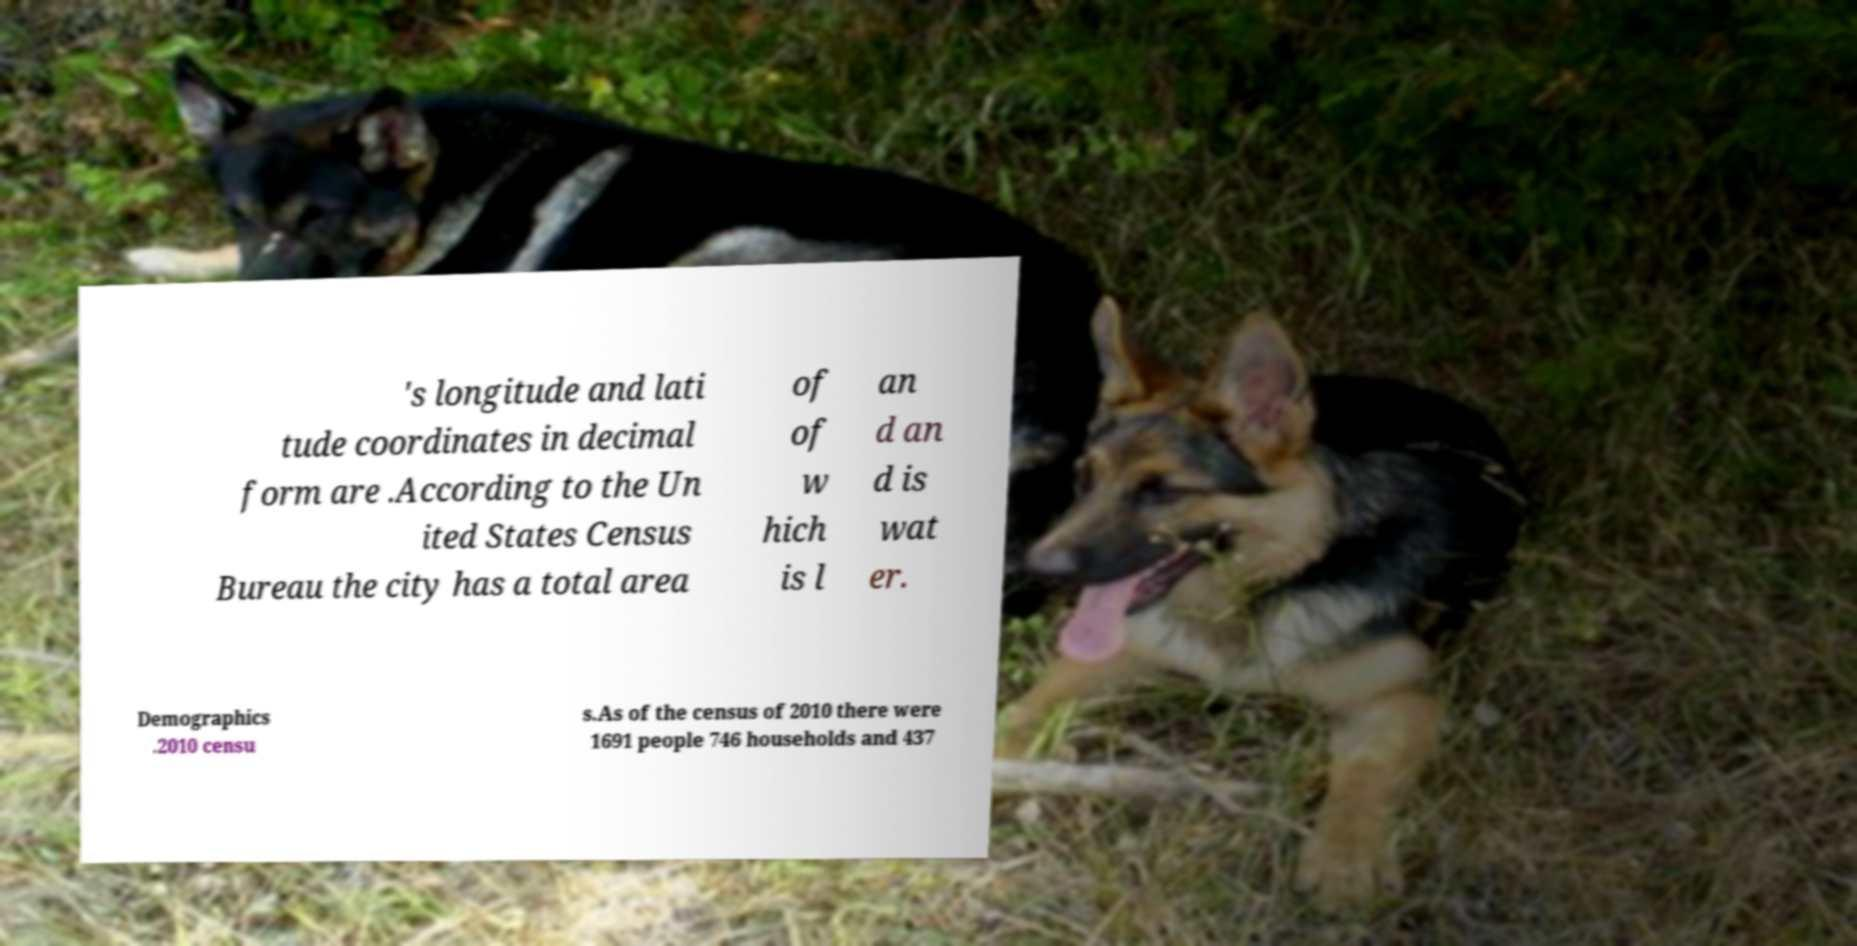Could you extract and type out the text from this image? 's longitude and lati tude coordinates in decimal form are .According to the Un ited States Census Bureau the city has a total area of of w hich is l an d an d is wat er. Demographics .2010 censu s.As of the census of 2010 there were 1691 people 746 households and 437 